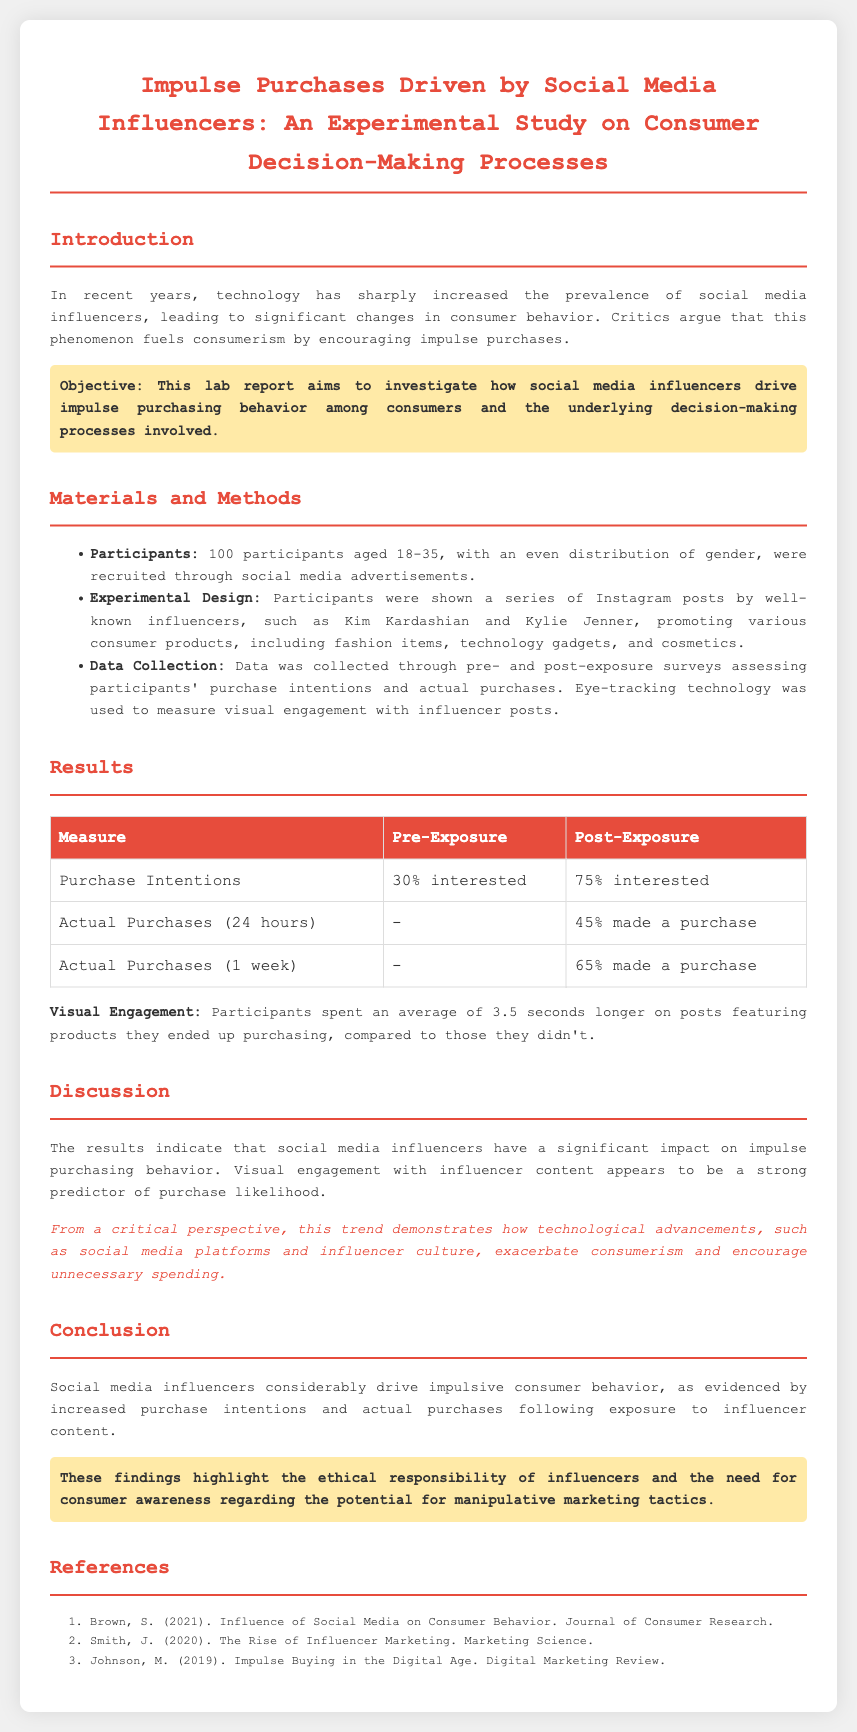what was the sample size of the study? The sample size of the study is specified in the materials and methods section, which states that 100 participants were recruited.
Answer: 100 participants what age range did the participants fall under? The age range of the participants is stated in the materials and methods section as 18-35.
Answer: 18-35 how much did purchase intentions increase from pre-exposure to post-exposure? The document provides figures for purchase intentions, showing an increase from 30% pre-exposure to 75% post-exposure, which gives a clear increase of 45 percentage points.
Answer: 45 percentage points what percentage of participants made a purchase within 24 hours after exposure? The results section indicates that 45% of participants made a purchase within 24 hours following exposure to influencer content.
Answer: 45% what was the average time spent on posts featuring purchased products? The document explains that participants spent an average of 3.5 seconds longer on posts featuring products they ended up purchasing, compared to those they didn't.
Answer: 3.5 seconds what is the main argument of the critique in the discussion section? The critique highlights that advancements in technology manifest through social media and influencer culture contributing to increased consumerism and unnecessary spending.
Answer: increased consumerism what category of products was NOT mentioned in the experimental design? The experimental design lists various products shown to participants but does not mention home appliances as a category featured.
Answer: home appliances what ethical responsibility is highlighted in the conclusion regarding influencers? The conclusion stresses the need for influencers to recognize their ethical responsibility in marketing, particularly around manipulative tactics.
Answer: ethical responsibility 